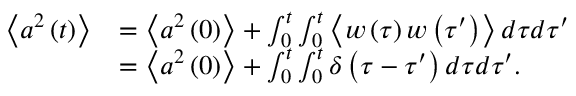<formula> <loc_0><loc_0><loc_500><loc_500>\begin{array} { r l } { \left \langle a ^ { 2 } \left ( t \right ) \right \rangle } & { = \left \langle a ^ { 2 } \left ( 0 \right ) \right \rangle + \int _ { 0 } ^ { t } \int _ { 0 } ^ { t } \left \langle w \left ( \tau \right ) w \left ( \tau ^ { \prime } \right ) \right \rangle d \tau d \tau ^ { \prime } } \\ & { = \left \langle a ^ { 2 } \left ( 0 \right ) \right \rangle + \int _ { 0 } ^ { t } \int _ { 0 } ^ { t } \delta \left ( \tau - \tau ^ { \prime } \right ) d \tau d \tau ^ { \prime } . } \end{array}</formula> 